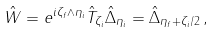Convert formula to latex. <formula><loc_0><loc_0><loc_500><loc_500>\hat { W } = e ^ { i \zeta _ { f } \wedge \eta _ { i } } \hat { T } _ { \zeta _ { i } } \hat { \Delta } _ { \eta _ { i } } = \hat { \Delta } _ { \eta _ { f } + \zeta _ { i } / 2 } \, ,</formula> 